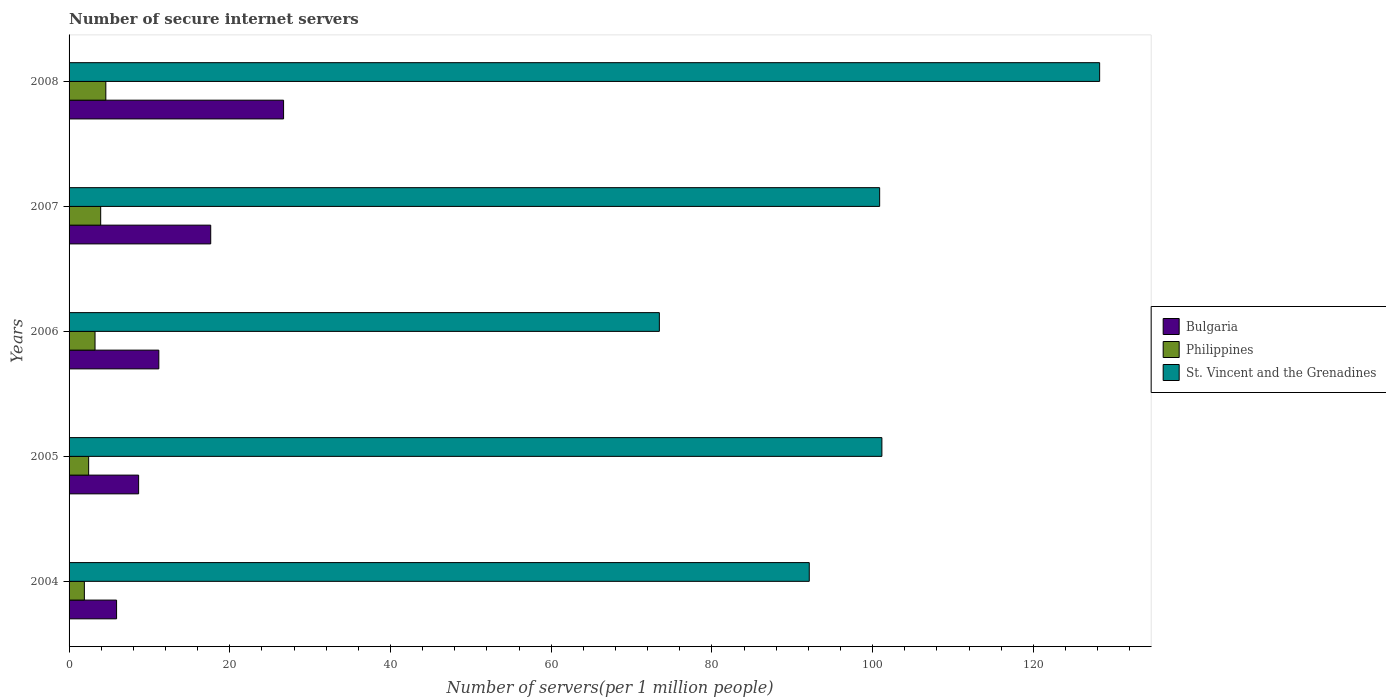How many different coloured bars are there?
Make the answer very short. 3. How many groups of bars are there?
Provide a short and direct response. 5. Are the number of bars on each tick of the Y-axis equal?
Provide a short and direct response. Yes. What is the label of the 1st group of bars from the top?
Your answer should be compact. 2008. In how many cases, is the number of bars for a given year not equal to the number of legend labels?
Give a very brief answer. 0. What is the number of secure internet servers in Bulgaria in 2005?
Offer a very short reply. 8.66. Across all years, what is the maximum number of secure internet servers in St. Vincent and the Grenadines?
Offer a terse response. 128.25. Across all years, what is the minimum number of secure internet servers in Philippines?
Ensure brevity in your answer.  1.9. In which year was the number of secure internet servers in Philippines maximum?
Offer a very short reply. 2008. What is the total number of secure internet servers in Bulgaria in the graph?
Give a very brief answer. 70.06. What is the difference between the number of secure internet servers in Philippines in 2005 and that in 2007?
Your answer should be compact. -1.5. What is the difference between the number of secure internet servers in Philippines in 2004 and the number of secure internet servers in Bulgaria in 2006?
Offer a terse response. -9.27. What is the average number of secure internet servers in Bulgaria per year?
Ensure brevity in your answer.  14.01. In the year 2007, what is the difference between the number of secure internet servers in Philippines and number of secure internet servers in St. Vincent and the Grenadines?
Your answer should be very brief. -96.94. In how many years, is the number of secure internet servers in St. Vincent and the Grenadines greater than 76 ?
Provide a short and direct response. 4. What is the ratio of the number of secure internet servers in St. Vincent and the Grenadines in 2004 to that in 2008?
Offer a terse response. 0.72. What is the difference between the highest and the second highest number of secure internet servers in Bulgaria?
Provide a short and direct response. 9.07. What is the difference between the highest and the lowest number of secure internet servers in Philippines?
Give a very brief answer. 2.67. In how many years, is the number of secure internet servers in St. Vincent and the Grenadines greater than the average number of secure internet servers in St. Vincent and the Grenadines taken over all years?
Offer a terse response. 3. Is the sum of the number of secure internet servers in Philippines in 2004 and 2005 greater than the maximum number of secure internet servers in St. Vincent and the Grenadines across all years?
Your answer should be very brief. No. What does the 1st bar from the top in 2008 represents?
Your answer should be very brief. St. Vincent and the Grenadines. What does the 1st bar from the bottom in 2007 represents?
Offer a very short reply. Bulgaria. How many bars are there?
Ensure brevity in your answer.  15. Are all the bars in the graph horizontal?
Keep it short and to the point. Yes. How many years are there in the graph?
Your answer should be very brief. 5. What is the title of the graph?
Give a very brief answer. Number of secure internet servers. What is the label or title of the X-axis?
Provide a succinct answer. Number of servers(per 1 million people). What is the label or title of the Y-axis?
Ensure brevity in your answer.  Years. What is the Number of servers(per 1 million people) in Bulgaria in 2004?
Offer a terse response. 5.91. What is the Number of servers(per 1 million people) of Philippines in 2004?
Provide a succinct answer. 1.9. What is the Number of servers(per 1 million people) in St. Vincent and the Grenadines in 2004?
Your answer should be very brief. 92.11. What is the Number of servers(per 1 million people) of Bulgaria in 2005?
Your response must be concise. 8.66. What is the Number of servers(per 1 million people) of Philippines in 2005?
Offer a terse response. 2.44. What is the Number of servers(per 1 million people) of St. Vincent and the Grenadines in 2005?
Offer a terse response. 101.15. What is the Number of servers(per 1 million people) of Bulgaria in 2006?
Provide a short and direct response. 11.17. What is the Number of servers(per 1 million people) in Philippines in 2006?
Offer a terse response. 3.23. What is the Number of servers(per 1 million people) in St. Vincent and the Grenadines in 2006?
Provide a short and direct response. 73.46. What is the Number of servers(per 1 million people) in Bulgaria in 2007?
Keep it short and to the point. 17.63. What is the Number of servers(per 1 million people) of Philippines in 2007?
Keep it short and to the point. 3.93. What is the Number of servers(per 1 million people) in St. Vincent and the Grenadines in 2007?
Your answer should be compact. 100.87. What is the Number of servers(per 1 million people) in Bulgaria in 2008?
Make the answer very short. 26.69. What is the Number of servers(per 1 million people) of Philippines in 2008?
Your answer should be compact. 4.57. What is the Number of servers(per 1 million people) in St. Vincent and the Grenadines in 2008?
Provide a succinct answer. 128.25. Across all years, what is the maximum Number of servers(per 1 million people) in Bulgaria?
Your answer should be compact. 26.69. Across all years, what is the maximum Number of servers(per 1 million people) in Philippines?
Keep it short and to the point. 4.57. Across all years, what is the maximum Number of servers(per 1 million people) in St. Vincent and the Grenadines?
Your response must be concise. 128.25. Across all years, what is the minimum Number of servers(per 1 million people) of Bulgaria?
Provide a succinct answer. 5.91. Across all years, what is the minimum Number of servers(per 1 million people) of Philippines?
Provide a succinct answer. 1.9. Across all years, what is the minimum Number of servers(per 1 million people) of St. Vincent and the Grenadines?
Provide a succinct answer. 73.46. What is the total Number of servers(per 1 million people) of Bulgaria in the graph?
Your response must be concise. 70.06. What is the total Number of servers(per 1 million people) in Philippines in the graph?
Offer a terse response. 16.08. What is the total Number of servers(per 1 million people) of St. Vincent and the Grenadines in the graph?
Provide a short and direct response. 495.84. What is the difference between the Number of servers(per 1 million people) in Bulgaria in 2004 and that in 2005?
Give a very brief answer. -2.74. What is the difference between the Number of servers(per 1 million people) of Philippines in 2004 and that in 2005?
Provide a short and direct response. -0.53. What is the difference between the Number of servers(per 1 million people) in St. Vincent and the Grenadines in 2004 and that in 2005?
Offer a terse response. -9.04. What is the difference between the Number of servers(per 1 million people) of Bulgaria in 2004 and that in 2006?
Keep it short and to the point. -5.26. What is the difference between the Number of servers(per 1 million people) in Philippines in 2004 and that in 2006?
Offer a terse response. -1.33. What is the difference between the Number of servers(per 1 million people) in St. Vincent and the Grenadines in 2004 and that in 2006?
Your answer should be compact. 18.66. What is the difference between the Number of servers(per 1 million people) in Bulgaria in 2004 and that in 2007?
Provide a short and direct response. -11.72. What is the difference between the Number of servers(per 1 million people) of Philippines in 2004 and that in 2007?
Make the answer very short. -2.03. What is the difference between the Number of servers(per 1 million people) in St. Vincent and the Grenadines in 2004 and that in 2007?
Keep it short and to the point. -8.76. What is the difference between the Number of servers(per 1 million people) of Bulgaria in 2004 and that in 2008?
Provide a short and direct response. -20.78. What is the difference between the Number of servers(per 1 million people) of Philippines in 2004 and that in 2008?
Keep it short and to the point. -2.67. What is the difference between the Number of servers(per 1 million people) of St. Vincent and the Grenadines in 2004 and that in 2008?
Give a very brief answer. -36.13. What is the difference between the Number of servers(per 1 million people) in Bulgaria in 2005 and that in 2006?
Offer a very short reply. -2.51. What is the difference between the Number of servers(per 1 million people) of Philippines in 2005 and that in 2006?
Offer a very short reply. -0.79. What is the difference between the Number of servers(per 1 million people) in St. Vincent and the Grenadines in 2005 and that in 2006?
Ensure brevity in your answer.  27.69. What is the difference between the Number of servers(per 1 million people) in Bulgaria in 2005 and that in 2007?
Give a very brief answer. -8.97. What is the difference between the Number of servers(per 1 million people) of Philippines in 2005 and that in 2007?
Your response must be concise. -1.5. What is the difference between the Number of servers(per 1 million people) of St. Vincent and the Grenadines in 2005 and that in 2007?
Your answer should be very brief. 0.28. What is the difference between the Number of servers(per 1 million people) of Bulgaria in 2005 and that in 2008?
Give a very brief answer. -18.04. What is the difference between the Number of servers(per 1 million people) of Philippines in 2005 and that in 2008?
Your answer should be very brief. -2.14. What is the difference between the Number of servers(per 1 million people) of St. Vincent and the Grenadines in 2005 and that in 2008?
Your answer should be very brief. -27.1. What is the difference between the Number of servers(per 1 million people) in Bulgaria in 2006 and that in 2007?
Give a very brief answer. -6.46. What is the difference between the Number of servers(per 1 million people) in Philippines in 2006 and that in 2007?
Provide a short and direct response. -0.7. What is the difference between the Number of servers(per 1 million people) in St. Vincent and the Grenadines in 2006 and that in 2007?
Ensure brevity in your answer.  -27.42. What is the difference between the Number of servers(per 1 million people) of Bulgaria in 2006 and that in 2008?
Your answer should be compact. -15.52. What is the difference between the Number of servers(per 1 million people) in Philippines in 2006 and that in 2008?
Make the answer very short. -1.34. What is the difference between the Number of servers(per 1 million people) of St. Vincent and the Grenadines in 2006 and that in 2008?
Your answer should be compact. -54.79. What is the difference between the Number of servers(per 1 million people) of Bulgaria in 2007 and that in 2008?
Make the answer very short. -9.07. What is the difference between the Number of servers(per 1 million people) in Philippines in 2007 and that in 2008?
Give a very brief answer. -0.64. What is the difference between the Number of servers(per 1 million people) of St. Vincent and the Grenadines in 2007 and that in 2008?
Offer a terse response. -27.37. What is the difference between the Number of servers(per 1 million people) in Bulgaria in 2004 and the Number of servers(per 1 million people) in Philippines in 2005?
Offer a terse response. 3.47. What is the difference between the Number of servers(per 1 million people) in Bulgaria in 2004 and the Number of servers(per 1 million people) in St. Vincent and the Grenadines in 2005?
Provide a succinct answer. -95.24. What is the difference between the Number of servers(per 1 million people) of Philippines in 2004 and the Number of servers(per 1 million people) of St. Vincent and the Grenadines in 2005?
Make the answer very short. -99.25. What is the difference between the Number of servers(per 1 million people) in Bulgaria in 2004 and the Number of servers(per 1 million people) in Philippines in 2006?
Provide a short and direct response. 2.68. What is the difference between the Number of servers(per 1 million people) of Bulgaria in 2004 and the Number of servers(per 1 million people) of St. Vincent and the Grenadines in 2006?
Give a very brief answer. -67.54. What is the difference between the Number of servers(per 1 million people) of Philippines in 2004 and the Number of servers(per 1 million people) of St. Vincent and the Grenadines in 2006?
Offer a very short reply. -71.55. What is the difference between the Number of servers(per 1 million people) in Bulgaria in 2004 and the Number of servers(per 1 million people) in Philippines in 2007?
Provide a short and direct response. 1.98. What is the difference between the Number of servers(per 1 million people) of Bulgaria in 2004 and the Number of servers(per 1 million people) of St. Vincent and the Grenadines in 2007?
Ensure brevity in your answer.  -94.96. What is the difference between the Number of servers(per 1 million people) in Philippines in 2004 and the Number of servers(per 1 million people) in St. Vincent and the Grenadines in 2007?
Keep it short and to the point. -98.97. What is the difference between the Number of servers(per 1 million people) in Bulgaria in 2004 and the Number of servers(per 1 million people) in Philippines in 2008?
Offer a terse response. 1.34. What is the difference between the Number of servers(per 1 million people) in Bulgaria in 2004 and the Number of servers(per 1 million people) in St. Vincent and the Grenadines in 2008?
Your answer should be compact. -122.33. What is the difference between the Number of servers(per 1 million people) of Philippines in 2004 and the Number of servers(per 1 million people) of St. Vincent and the Grenadines in 2008?
Ensure brevity in your answer.  -126.34. What is the difference between the Number of servers(per 1 million people) of Bulgaria in 2005 and the Number of servers(per 1 million people) of Philippines in 2006?
Your answer should be very brief. 5.43. What is the difference between the Number of servers(per 1 million people) of Bulgaria in 2005 and the Number of servers(per 1 million people) of St. Vincent and the Grenadines in 2006?
Make the answer very short. -64.8. What is the difference between the Number of servers(per 1 million people) in Philippines in 2005 and the Number of servers(per 1 million people) in St. Vincent and the Grenadines in 2006?
Your response must be concise. -71.02. What is the difference between the Number of servers(per 1 million people) in Bulgaria in 2005 and the Number of servers(per 1 million people) in Philippines in 2007?
Offer a very short reply. 4.72. What is the difference between the Number of servers(per 1 million people) of Bulgaria in 2005 and the Number of servers(per 1 million people) of St. Vincent and the Grenadines in 2007?
Give a very brief answer. -92.22. What is the difference between the Number of servers(per 1 million people) of Philippines in 2005 and the Number of servers(per 1 million people) of St. Vincent and the Grenadines in 2007?
Your answer should be compact. -98.43. What is the difference between the Number of servers(per 1 million people) of Bulgaria in 2005 and the Number of servers(per 1 million people) of Philippines in 2008?
Offer a very short reply. 4.08. What is the difference between the Number of servers(per 1 million people) in Bulgaria in 2005 and the Number of servers(per 1 million people) in St. Vincent and the Grenadines in 2008?
Your answer should be compact. -119.59. What is the difference between the Number of servers(per 1 million people) of Philippines in 2005 and the Number of servers(per 1 million people) of St. Vincent and the Grenadines in 2008?
Make the answer very short. -125.81. What is the difference between the Number of servers(per 1 million people) of Bulgaria in 2006 and the Number of servers(per 1 million people) of Philippines in 2007?
Your answer should be very brief. 7.24. What is the difference between the Number of servers(per 1 million people) of Bulgaria in 2006 and the Number of servers(per 1 million people) of St. Vincent and the Grenadines in 2007?
Keep it short and to the point. -89.7. What is the difference between the Number of servers(per 1 million people) in Philippines in 2006 and the Number of servers(per 1 million people) in St. Vincent and the Grenadines in 2007?
Your answer should be very brief. -97.64. What is the difference between the Number of servers(per 1 million people) of Bulgaria in 2006 and the Number of servers(per 1 million people) of Philippines in 2008?
Provide a short and direct response. 6.6. What is the difference between the Number of servers(per 1 million people) in Bulgaria in 2006 and the Number of servers(per 1 million people) in St. Vincent and the Grenadines in 2008?
Your answer should be very brief. -117.08. What is the difference between the Number of servers(per 1 million people) in Philippines in 2006 and the Number of servers(per 1 million people) in St. Vincent and the Grenadines in 2008?
Make the answer very short. -125.02. What is the difference between the Number of servers(per 1 million people) in Bulgaria in 2007 and the Number of servers(per 1 million people) in Philippines in 2008?
Keep it short and to the point. 13.05. What is the difference between the Number of servers(per 1 million people) of Bulgaria in 2007 and the Number of servers(per 1 million people) of St. Vincent and the Grenadines in 2008?
Keep it short and to the point. -110.62. What is the difference between the Number of servers(per 1 million people) of Philippines in 2007 and the Number of servers(per 1 million people) of St. Vincent and the Grenadines in 2008?
Offer a very short reply. -124.31. What is the average Number of servers(per 1 million people) of Bulgaria per year?
Make the answer very short. 14.01. What is the average Number of servers(per 1 million people) in Philippines per year?
Your response must be concise. 3.22. What is the average Number of servers(per 1 million people) of St. Vincent and the Grenadines per year?
Make the answer very short. 99.17. In the year 2004, what is the difference between the Number of servers(per 1 million people) in Bulgaria and Number of servers(per 1 million people) in Philippines?
Offer a very short reply. 4.01. In the year 2004, what is the difference between the Number of servers(per 1 million people) in Bulgaria and Number of servers(per 1 million people) in St. Vincent and the Grenadines?
Your answer should be compact. -86.2. In the year 2004, what is the difference between the Number of servers(per 1 million people) of Philippines and Number of servers(per 1 million people) of St. Vincent and the Grenadines?
Make the answer very short. -90.21. In the year 2005, what is the difference between the Number of servers(per 1 million people) of Bulgaria and Number of servers(per 1 million people) of Philippines?
Offer a very short reply. 6.22. In the year 2005, what is the difference between the Number of servers(per 1 million people) of Bulgaria and Number of servers(per 1 million people) of St. Vincent and the Grenadines?
Keep it short and to the point. -92.49. In the year 2005, what is the difference between the Number of servers(per 1 million people) of Philippines and Number of servers(per 1 million people) of St. Vincent and the Grenadines?
Make the answer very short. -98.71. In the year 2006, what is the difference between the Number of servers(per 1 million people) in Bulgaria and Number of servers(per 1 million people) in Philippines?
Give a very brief answer. 7.94. In the year 2006, what is the difference between the Number of servers(per 1 million people) in Bulgaria and Number of servers(per 1 million people) in St. Vincent and the Grenadines?
Your answer should be compact. -62.29. In the year 2006, what is the difference between the Number of servers(per 1 million people) in Philippines and Number of servers(per 1 million people) in St. Vincent and the Grenadines?
Ensure brevity in your answer.  -70.23. In the year 2007, what is the difference between the Number of servers(per 1 million people) of Bulgaria and Number of servers(per 1 million people) of Philippines?
Ensure brevity in your answer.  13.69. In the year 2007, what is the difference between the Number of servers(per 1 million people) in Bulgaria and Number of servers(per 1 million people) in St. Vincent and the Grenadines?
Offer a very short reply. -83.25. In the year 2007, what is the difference between the Number of servers(per 1 million people) in Philippines and Number of servers(per 1 million people) in St. Vincent and the Grenadines?
Provide a succinct answer. -96.94. In the year 2008, what is the difference between the Number of servers(per 1 million people) in Bulgaria and Number of servers(per 1 million people) in Philippines?
Offer a terse response. 22.12. In the year 2008, what is the difference between the Number of servers(per 1 million people) in Bulgaria and Number of servers(per 1 million people) in St. Vincent and the Grenadines?
Provide a succinct answer. -101.55. In the year 2008, what is the difference between the Number of servers(per 1 million people) of Philippines and Number of servers(per 1 million people) of St. Vincent and the Grenadines?
Keep it short and to the point. -123.67. What is the ratio of the Number of servers(per 1 million people) of Bulgaria in 2004 to that in 2005?
Keep it short and to the point. 0.68. What is the ratio of the Number of servers(per 1 million people) of Philippines in 2004 to that in 2005?
Give a very brief answer. 0.78. What is the ratio of the Number of servers(per 1 million people) of St. Vincent and the Grenadines in 2004 to that in 2005?
Offer a very short reply. 0.91. What is the ratio of the Number of servers(per 1 million people) of Bulgaria in 2004 to that in 2006?
Your answer should be compact. 0.53. What is the ratio of the Number of servers(per 1 million people) of Philippines in 2004 to that in 2006?
Your answer should be very brief. 0.59. What is the ratio of the Number of servers(per 1 million people) in St. Vincent and the Grenadines in 2004 to that in 2006?
Offer a very short reply. 1.25. What is the ratio of the Number of servers(per 1 million people) in Bulgaria in 2004 to that in 2007?
Provide a succinct answer. 0.34. What is the ratio of the Number of servers(per 1 million people) in Philippines in 2004 to that in 2007?
Provide a succinct answer. 0.48. What is the ratio of the Number of servers(per 1 million people) of St. Vincent and the Grenadines in 2004 to that in 2007?
Provide a succinct answer. 0.91. What is the ratio of the Number of servers(per 1 million people) in Bulgaria in 2004 to that in 2008?
Give a very brief answer. 0.22. What is the ratio of the Number of servers(per 1 million people) in Philippines in 2004 to that in 2008?
Ensure brevity in your answer.  0.42. What is the ratio of the Number of servers(per 1 million people) in St. Vincent and the Grenadines in 2004 to that in 2008?
Make the answer very short. 0.72. What is the ratio of the Number of servers(per 1 million people) in Bulgaria in 2005 to that in 2006?
Give a very brief answer. 0.78. What is the ratio of the Number of servers(per 1 million people) of Philippines in 2005 to that in 2006?
Provide a succinct answer. 0.75. What is the ratio of the Number of servers(per 1 million people) of St. Vincent and the Grenadines in 2005 to that in 2006?
Offer a terse response. 1.38. What is the ratio of the Number of servers(per 1 million people) of Bulgaria in 2005 to that in 2007?
Give a very brief answer. 0.49. What is the ratio of the Number of servers(per 1 million people) of Philippines in 2005 to that in 2007?
Your answer should be compact. 0.62. What is the ratio of the Number of servers(per 1 million people) of St. Vincent and the Grenadines in 2005 to that in 2007?
Give a very brief answer. 1. What is the ratio of the Number of servers(per 1 million people) of Bulgaria in 2005 to that in 2008?
Your answer should be very brief. 0.32. What is the ratio of the Number of servers(per 1 million people) of Philippines in 2005 to that in 2008?
Give a very brief answer. 0.53. What is the ratio of the Number of servers(per 1 million people) of St. Vincent and the Grenadines in 2005 to that in 2008?
Offer a very short reply. 0.79. What is the ratio of the Number of servers(per 1 million people) of Bulgaria in 2006 to that in 2007?
Provide a succinct answer. 0.63. What is the ratio of the Number of servers(per 1 million people) of Philippines in 2006 to that in 2007?
Make the answer very short. 0.82. What is the ratio of the Number of servers(per 1 million people) of St. Vincent and the Grenadines in 2006 to that in 2007?
Offer a very short reply. 0.73. What is the ratio of the Number of servers(per 1 million people) of Bulgaria in 2006 to that in 2008?
Keep it short and to the point. 0.42. What is the ratio of the Number of servers(per 1 million people) of Philippines in 2006 to that in 2008?
Ensure brevity in your answer.  0.71. What is the ratio of the Number of servers(per 1 million people) in St. Vincent and the Grenadines in 2006 to that in 2008?
Provide a succinct answer. 0.57. What is the ratio of the Number of servers(per 1 million people) in Bulgaria in 2007 to that in 2008?
Your answer should be compact. 0.66. What is the ratio of the Number of servers(per 1 million people) of Philippines in 2007 to that in 2008?
Ensure brevity in your answer.  0.86. What is the ratio of the Number of servers(per 1 million people) in St. Vincent and the Grenadines in 2007 to that in 2008?
Provide a short and direct response. 0.79. What is the difference between the highest and the second highest Number of servers(per 1 million people) in Bulgaria?
Your answer should be very brief. 9.07. What is the difference between the highest and the second highest Number of servers(per 1 million people) in Philippines?
Offer a very short reply. 0.64. What is the difference between the highest and the second highest Number of servers(per 1 million people) of St. Vincent and the Grenadines?
Your answer should be compact. 27.1. What is the difference between the highest and the lowest Number of servers(per 1 million people) of Bulgaria?
Your answer should be very brief. 20.78. What is the difference between the highest and the lowest Number of servers(per 1 million people) of Philippines?
Your answer should be compact. 2.67. What is the difference between the highest and the lowest Number of servers(per 1 million people) in St. Vincent and the Grenadines?
Ensure brevity in your answer.  54.79. 